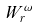<formula> <loc_0><loc_0><loc_500><loc_500>W _ { r } ^ { \omega }</formula> 